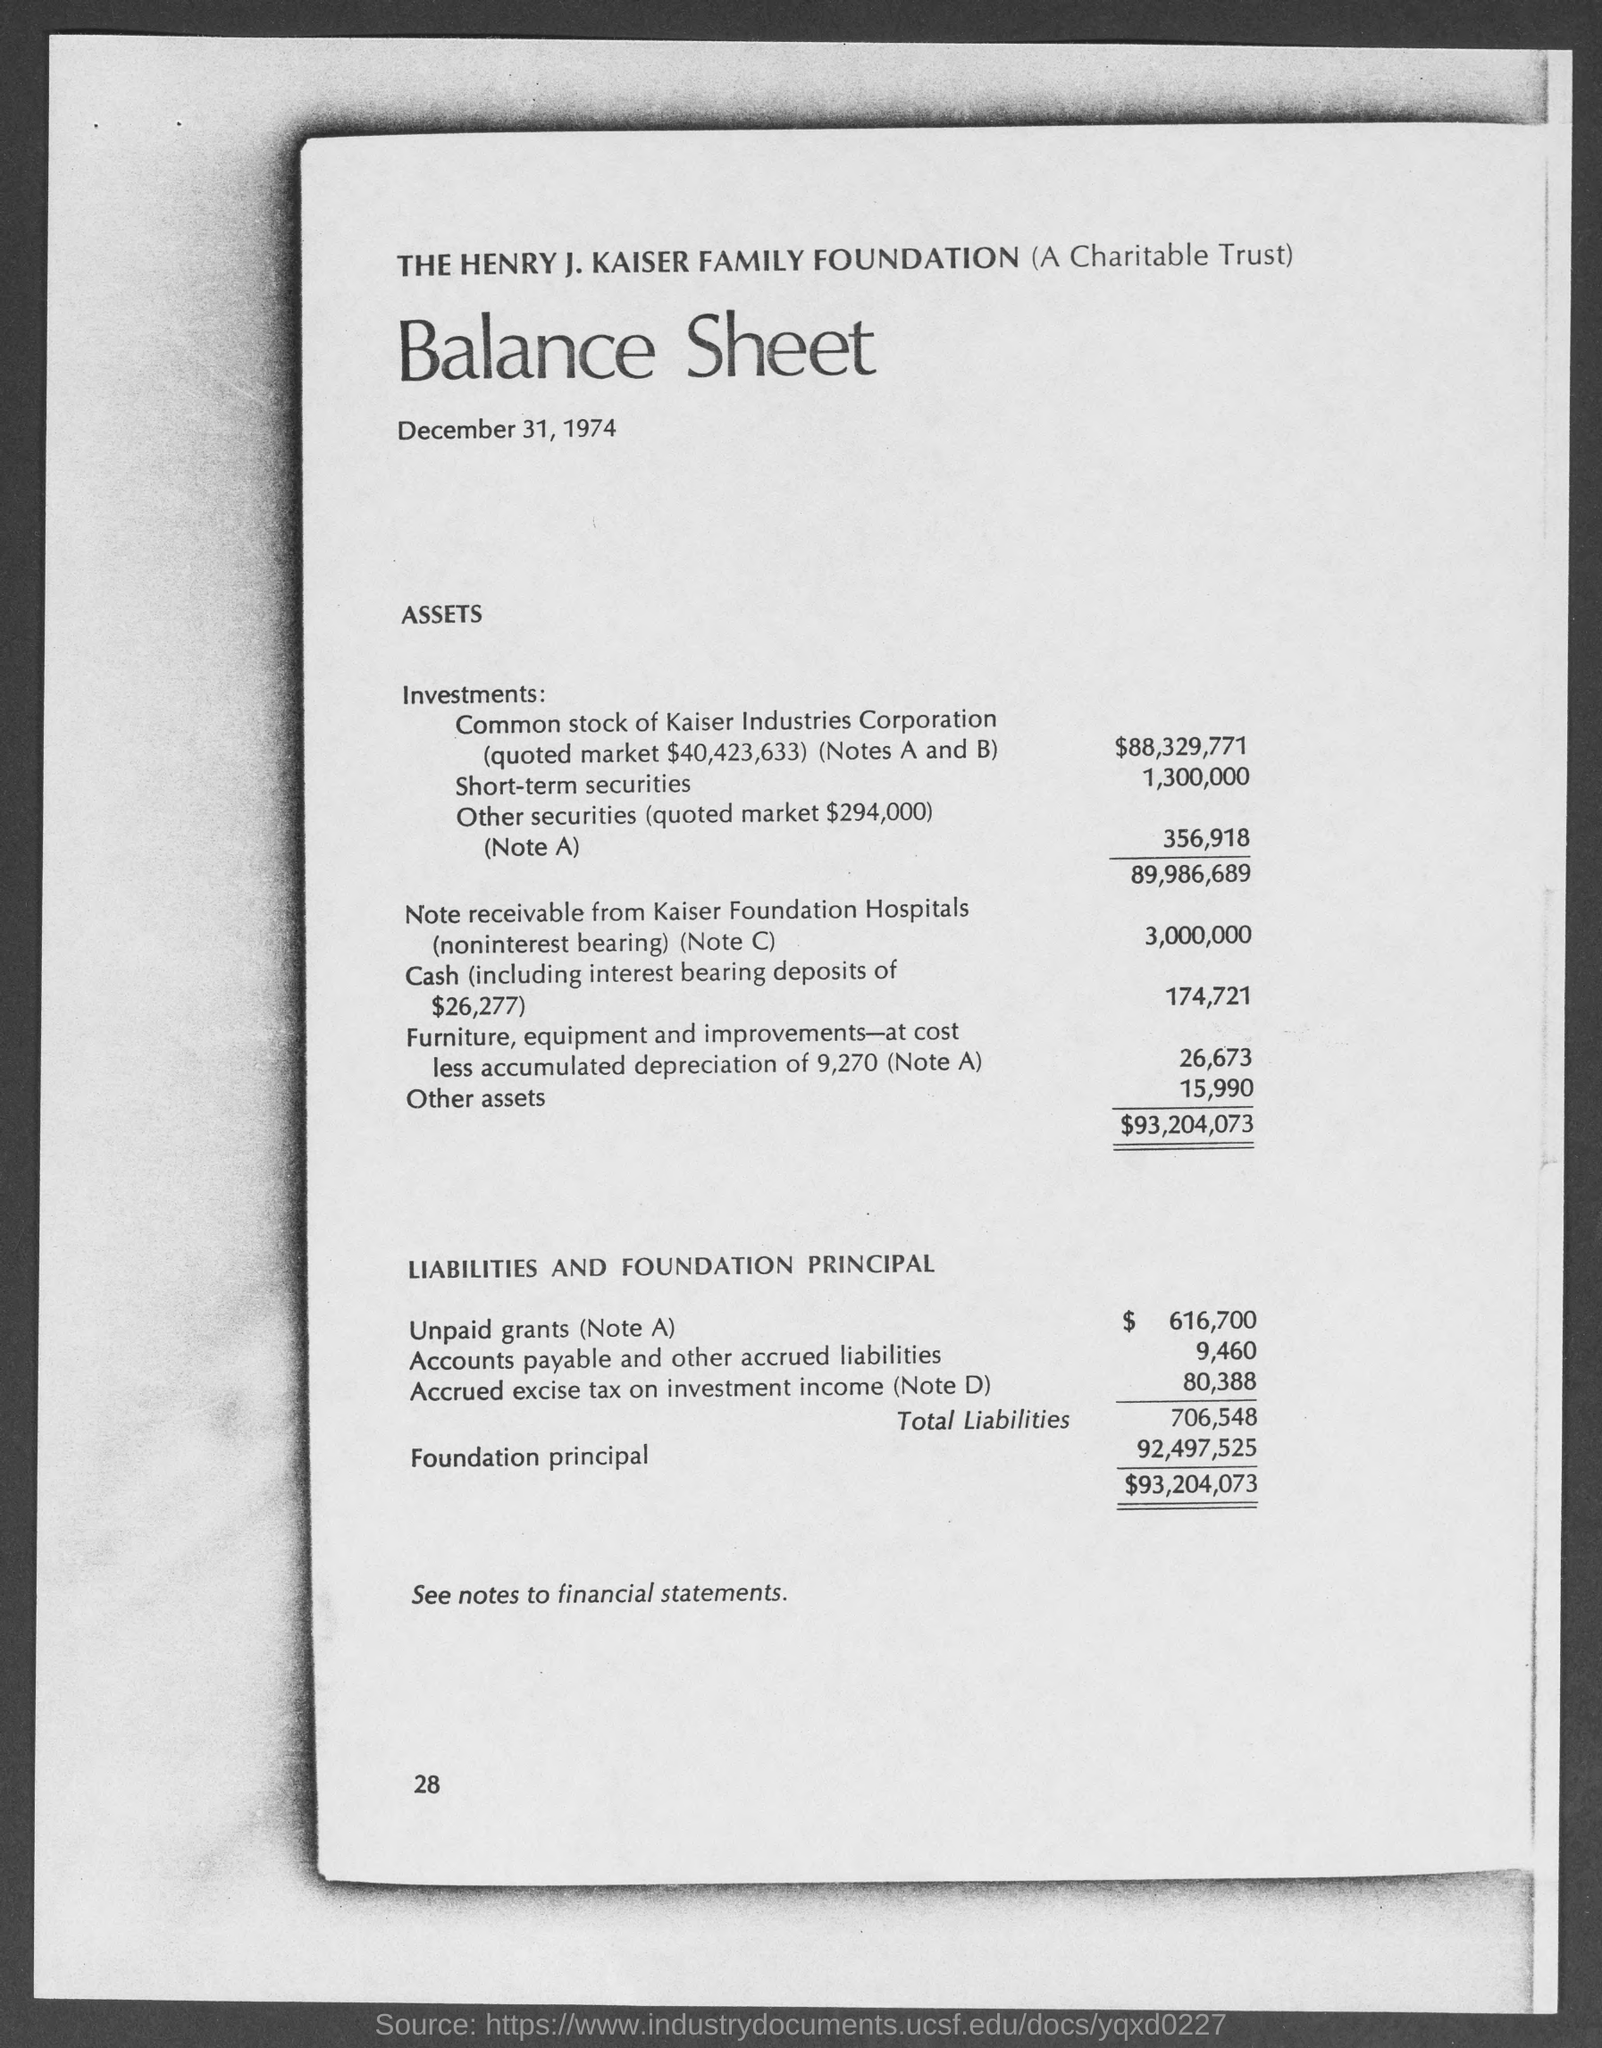What is the name of the foundation ?
Your answer should be compact. The Henry J. Kaiser Family Foundation. What is the date mentioned in the given balance sheet ?
Provide a short and direct response. December 31, 1974. What is the amount of common stock of kaiser industries corporation ?
Keep it short and to the point. $88,329,771. What is the amount of short term securities ?
Ensure brevity in your answer.  1,300,000. What is the amount of other securities ?
Your answer should be compact. 356,918. What is the amount of unpaid grants(note a) ?
Your answer should be very brief. $ 616,700. What is the amount of accounts payable and other accured liabilities ?
Your answer should be compact. 9,460. What is the amount of accrued excise tax on investment income (note d) ?
Provide a short and direct response. 80,388. What is the amount of foundation principal ?
Your response must be concise. 92,497,525. 